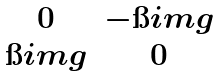<formula> <loc_0><loc_0><loc_500><loc_500>\begin{matrix} 0 & - \i i m g \\ \i i m g & 0 \end{matrix}</formula> 